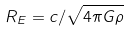<formula> <loc_0><loc_0><loc_500><loc_500>R _ { E } = c / \sqrt { 4 \pi G \rho }</formula> 